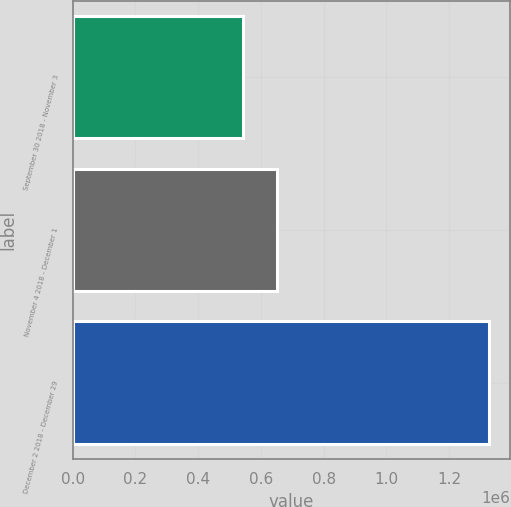Convert chart. <chart><loc_0><loc_0><loc_500><loc_500><bar_chart><fcel>September 30 2018 - November 3<fcel>November 4 2018 - December 1<fcel>December 2 2018 - December 29<nl><fcel>543900<fcel>650048<fcel>1.32766e+06<nl></chart> 